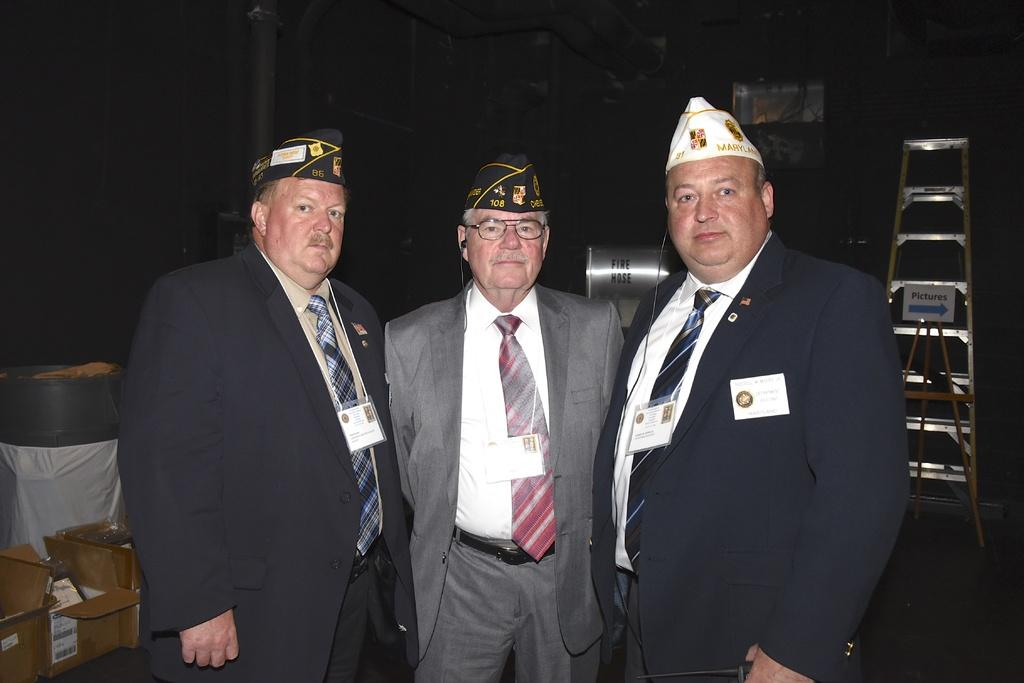What type of people are in the image? There are men in the image. What are the men doing in the image? The men are standing. What are the men wearing in the image? The men are wearing formal suits and caps on their heads. What type of curve can be seen in the image? There is no curve present in the image; it features men standing and wearing formal suits and caps. 